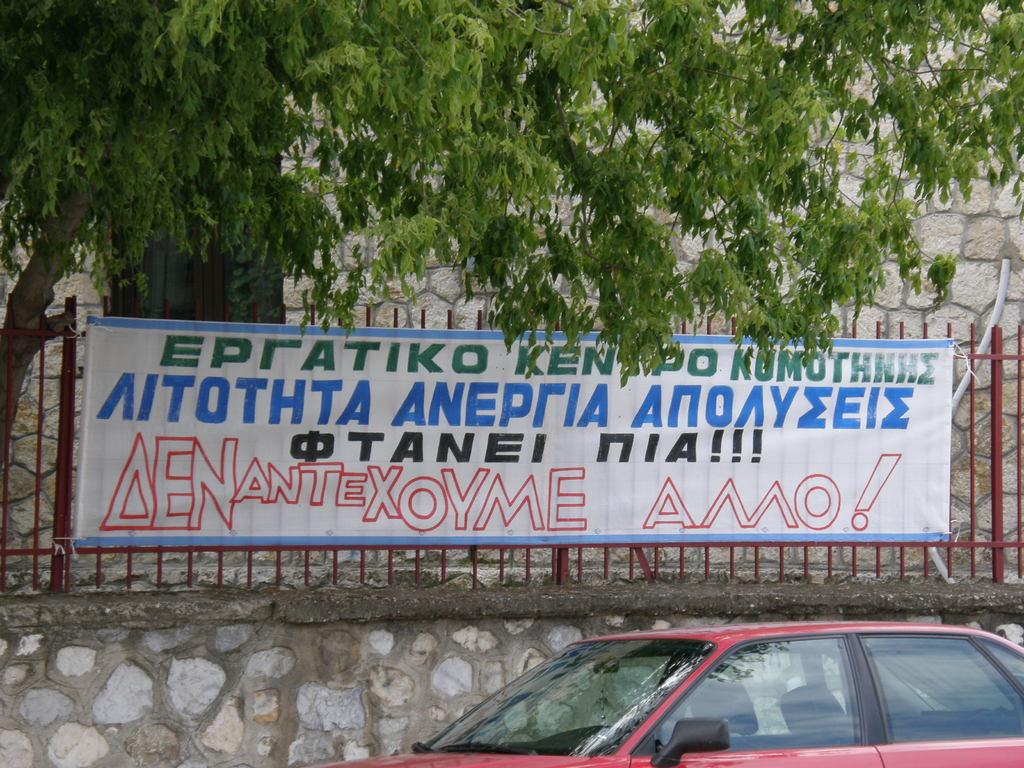What is the main subject of the image? There is a vehicle in the image. What is written on the board in the image? There is a board with text on the railing. What can be seen in the background of the image? There is a tree and a wall in the background of the image. What type of butter is being used to grease the boys' hands in the image? There are no boys or butter present in the image; it features a vehicle and a board with text on the railing. 